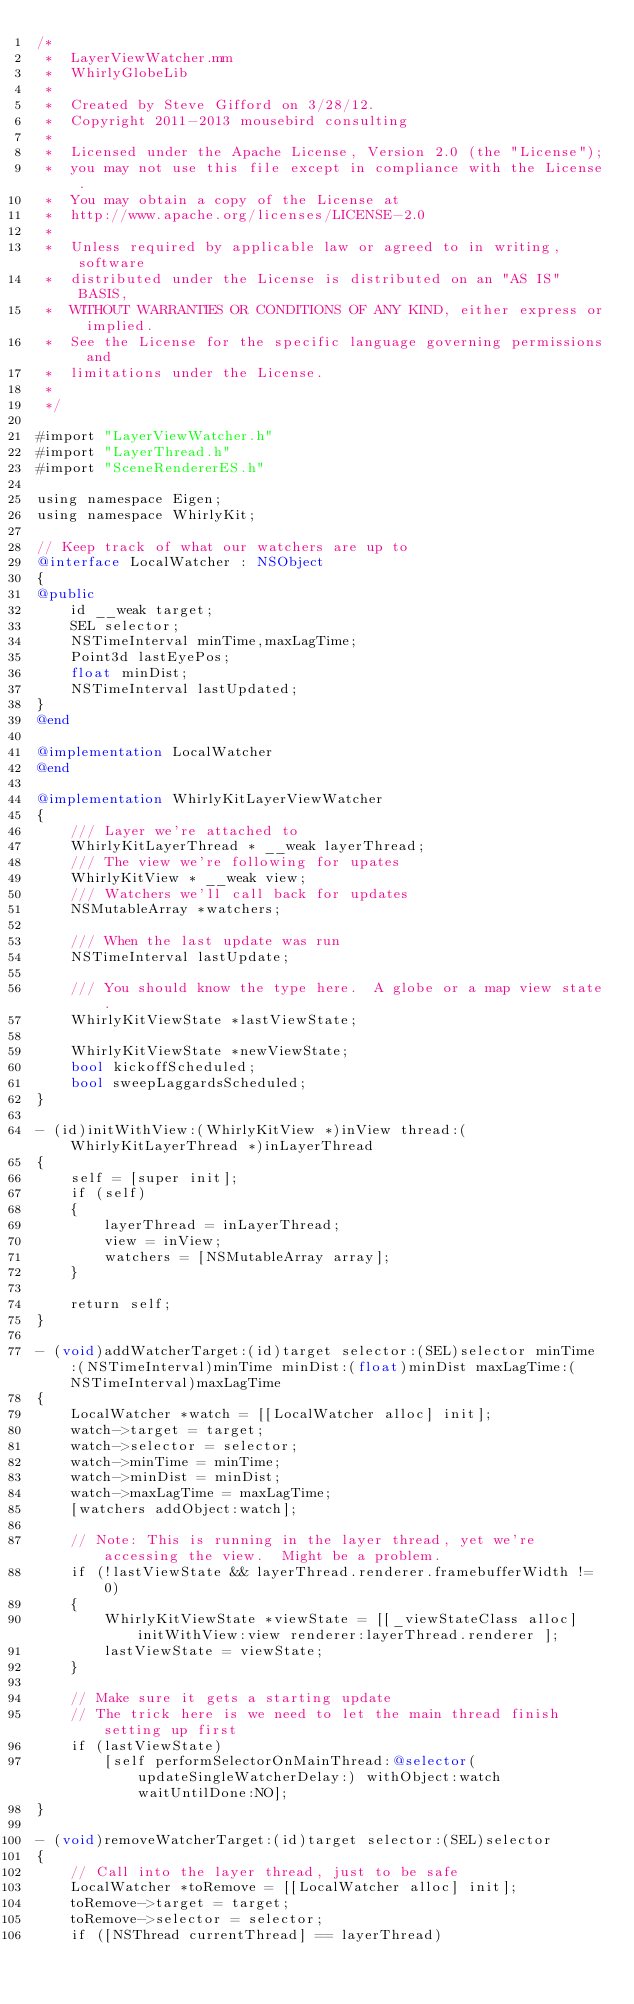<code> <loc_0><loc_0><loc_500><loc_500><_ObjectiveC_>/*
 *  LayerViewWatcher.mm
 *  WhirlyGlobeLib
 *
 *  Created by Steve Gifford on 3/28/12.
 *  Copyright 2011-2013 mousebird consulting
 *
 *  Licensed under the Apache License, Version 2.0 (the "License");
 *  you may not use this file except in compliance with the License.
 *  You may obtain a copy of the License at
 *  http://www.apache.org/licenses/LICENSE-2.0
 *
 *  Unless required by applicable law or agreed to in writing, software
 *  distributed under the License is distributed on an "AS IS" BASIS,
 *  WITHOUT WARRANTIES OR CONDITIONS OF ANY KIND, either express or implied.
 *  See the License for the specific language governing permissions and
 *  limitations under the License.
 *
 */

#import "LayerViewWatcher.h"
#import "LayerThread.h"
#import "SceneRendererES.h"

using namespace Eigen;
using namespace WhirlyKit;

// Keep track of what our watchers are up to
@interface LocalWatcher : NSObject
{
@public
    id __weak target;
    SEL selector;
    NSTimeInterval minTime,maxLagTime;
    Point3d lastEyePos;
    float minDist;
    NSTimeInterval lastUpdated;
}
@end

@implementation LocalWatcher
@end

@implementation WhirlyKitLayerViewWatcher
{
    /// Layer we're attached to
    WhirlyKitLayerThread * __weak layerThread;
    /// The view we're following for upates
    WhirlyKitView * __weak view;
    /// Watchers we'll call back for updates
    NSMutableArray *watchers;
    
    /// When the last update was run
    NSTimeInterval lastUpdate;
    
    /// You should know the type here.  A globe or a map view state.
    WhirlyKitViewState *lastViewState;
    
    WhirlyKitViewState *newViewState;
    bool kickoffScheduled;
    bool sweepLaggardsScheduled;
}

- (id)initWithView:(WhirlyKitView *)inView thread:(WhirlyKitLayerThread *)inLayerThread
{
    self = [super init];
    if (self)
    {
        layerThread = inLayerThread;
        view = inView;
        watchers = [NSMutableArray array];
    }
    
    return self;
}

- (void)addWatcherTarget:(id)target selector:(SEL)selector minTime:(NSTimeInterval)minTime minDist:(float)minDist maxLagTime:(NSTimeInterval)maxLagTime
{
    LocalWatcher *watch = [[LocalWatcher alloc] init];
    watch->target = target;
    watch->selector = selector;
    watch->minTime = minTime;
    watch->minDist = minDist;
    watch->maxLagTime = maxLagTime;
    [watchers addObject:watch];
    
    // Note: This is running in the layer thread, yet we're accessing the view.  Might be a problem.
    if (!lastViewState && layerThread.renderer.framebufferWidth != 0)
    {
        WhirlyKitViewState *viewState = [[_viewStateClass alloc] initWithView:view renderer:layerThread.renderer ];
        lastViewState = viewState;
    }
    
    // Make sure it gets a starting update
    // The trick here is we need to let the main thread finish setting up first
    if (lastViewState)
        [self performSelectorOnMainThread:@selector(updateSingleWatcherDelay:) withObject:watch waitUntilDone:NO];
}

- (void)removeWatcherTarget:(id)target selector:(SEL)selector
{
    // Call into the layer thread, just to be safe
    LocalWatcher *toRemove = [[LocalWatcher alloc] init];
    toRemove->target = target;
    toRemove->selector = selector;
    if ([NSThread currentThread] == layerThread)</code> 